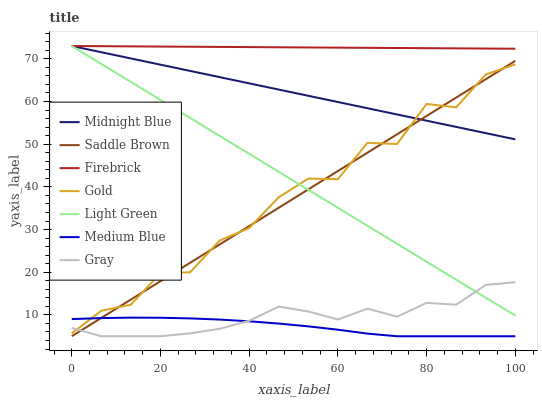Does Medium Blue have the minimum area under the curve?
Answer yes or no. Yes. Does Firebrick have the maximum area under the curve?
Answer yes or no. Yes. Does Midnight Blue have the minimum area under the curve?
Answer yes or no. No. Does Midnight Blue have the maximum area under the curve?
Answer yes or no. No. Is Saddle Brown the smoothest?
Answer yes or no. Yes. Is Gold the roughest?
Answer yes or no. Yes. Is Midnight Blue the smoothest?
Answer yes or no. No. Is Midnight Blue the roughest?
Answer yes or no. No. Does Gray have the lowest value?
Answer yes or no. Yes. Does Midnight Blue have the lowest value?
Answer yes or no. No. Does Light Green have the highest value?
Answer yes or no. Yes. Does Gold have the highest value?
Answer yes or no. No. Is Saddle Brown less than Firebrick?
Answer yes or no. Yes. Is Firebrick greater than Saddle Brown?
Answer yes or no. Yes. Does Light Green intersect Midnight Blue?
Answer yes or no. Yes. Is Light Green less than Midnight Blue?
Answer yes or no. No. Is Light Green greater than Midnight Blue?
Answer yes or no. No. Does Saddle Brown intersect Firebrick?
Answer yes or no. No. 